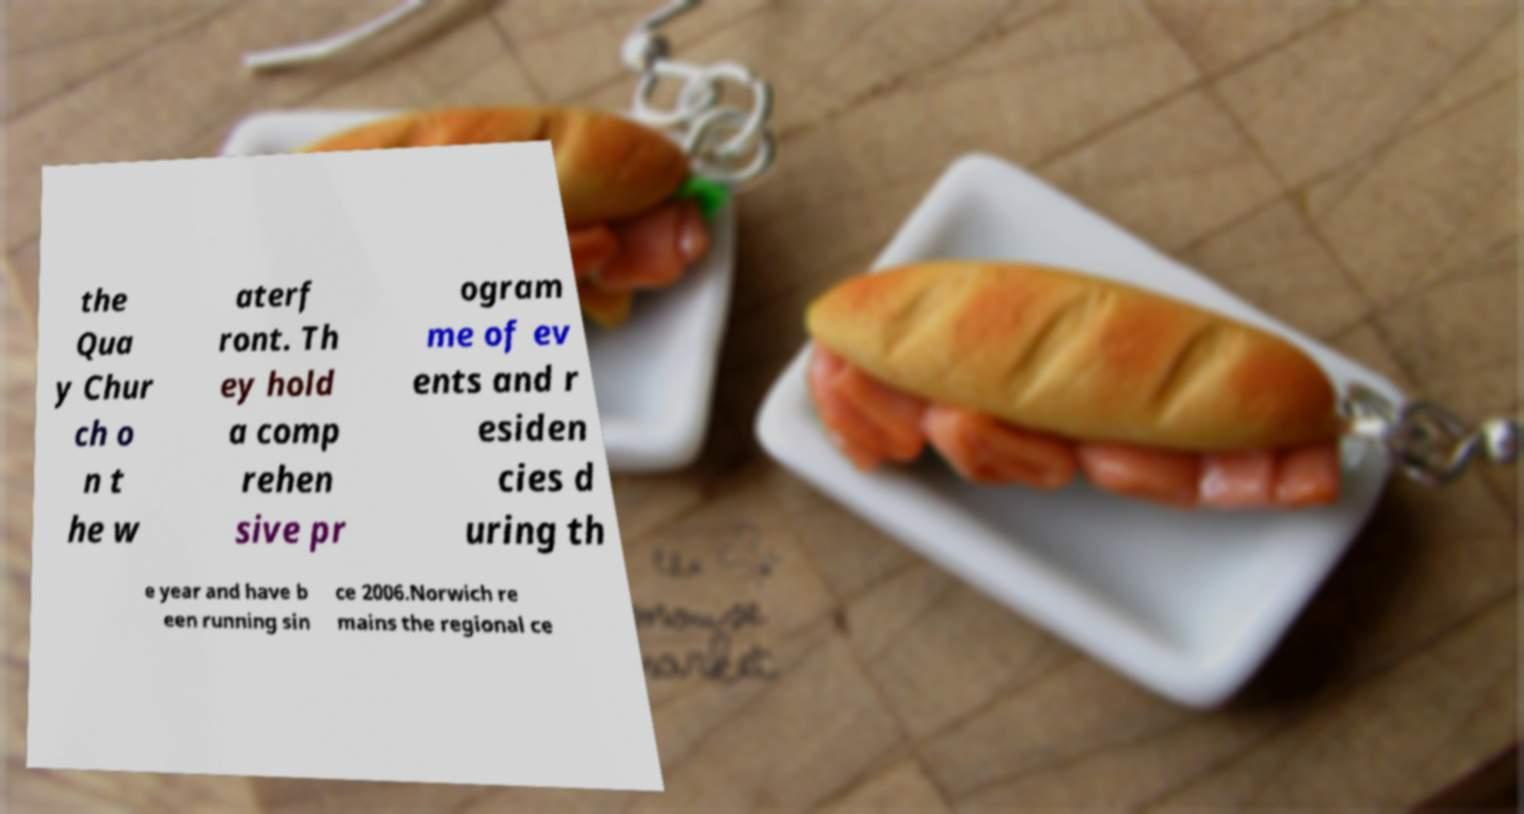What messages or text are displayed in this image? I need them in a readable, typed format. the Qua y Chur ch o n t he w aterf ront. Th ey hold a comp rehen sive pr ogram me of ev ents and r esiden cies d uring th e year and have b een running sin ce 2006.Norwich re mains the regional ce 